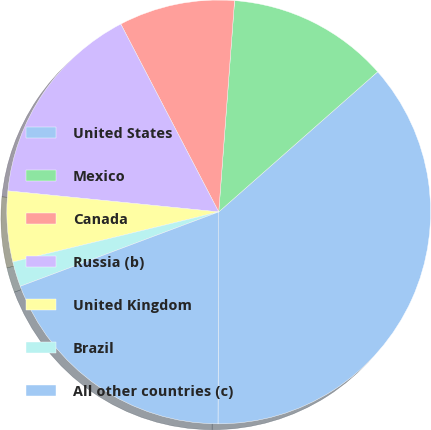<chart> <loc_0><loc_0><loc_500><loc_500><pie_chart><fcel>United States<fcel>Mexico<fcel>Canada<fcel>Russia (b)<fcel>United Kingdom<fcel>Brazil<fcel>All other countries (c)<nl><fcel>36.56%<fcel>12.31%<fcel>8.84%<fcel>15.77%<fcel>5.38%<fcel>1.91%<fcel>19.24%<nl></chart> 